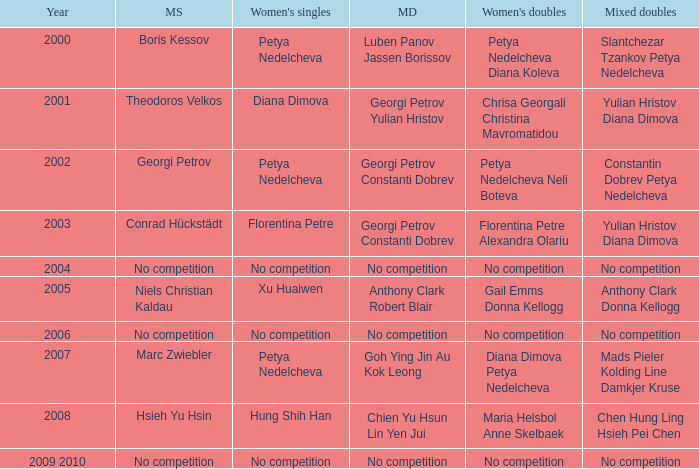In what year was there no competition for women? 2004, 2006, 2009 2010. Could you help me parse every detail presented in this table? {'header': ['Year', 'MS', "Women's singles", 'MD', "Women's doubles", 'Mixed doubles'], 'rows': [['2000', 'Boris Kessov', 'Petya Nedelcheva', 'Luben Panov Jassen Borissov', 'Petya Nedelcheva Diana Koleva', 'Slantchezar Tzankov Petya Nedelcheva'], ['2001', 'Theodoros Velkos', 'Diana Dimova', 'Georgi Petrov Yulian Hristov', 'Chrisa Georgali Christina Mavromatidou', 'Yulian Hristov Diana Dimova'], ['2002', 'Georgi Petrov', 'Petya Nedelcheva', 'Georgi Petrov Constanti Dobrev', 'Petya Nedelcheva Neli Boteva', 'Constantin Dobrev Petya Nedelcheva'], ['2003', 'Conrad Hückstädt', 'Florentina Petre', 'Georgi Petrov Constanti Dobrev', 'Florentina Petre Alexandra Olariu', 'Yulian Hristov Diana Dimova'], ['2004', 'No competition', 'No competition', 'No competition', 'No competition', 'No competition'], ['2005', 'Niels Christian Kaldau', 'Xu Huaiwen', 'Anthony Clark Robert Blair', 'Gail Emms Donna Kellogg', 'Anthony Clark Donna Kellogg'], ['2006', 'No competition', 'No competition', 'No competition', 'No competition', 'No competition'], ['2007', 'Marc Zwiebler', 'Petya Nedelcheva', 'Goh Ying Jin Au Kok Leong', 'Diana Dimova Petya Nedelcheva', 'Mads Pieler Kolding Line Damkjer Kruse'], ['2008', 'Hsieh Yu Hsin', 'Hung Shih Han', 'Chien Yu Hsun Lin Yen Jui', 'Maria Helsbol Anne Skelbaek', 'Chen Hung Ling Hsieh Pei Chen'], ['2009 2010', 'No competition', 'No competition', 'No competition', 'No competition', 'No competition']]} 